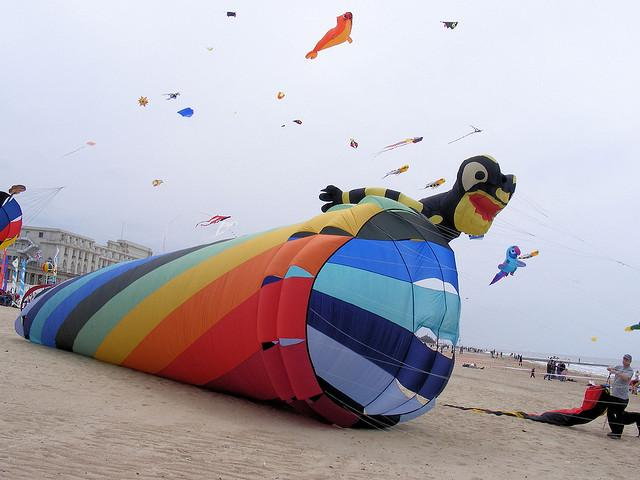What is the large item on the sand shaped like?

Choices:
A) ant
B) basketball
C) elephant
D) traffic cone traffic cone 